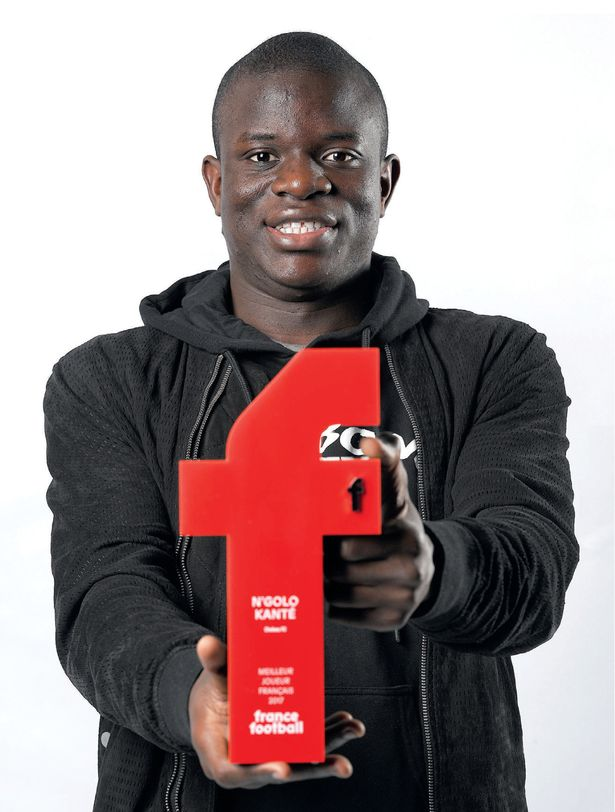How might this award impact the individual's future career and opportunities? Earning the 'Player of the Year' award can significantly impact the individual’s future career and opportunities. It increases his visibility and reputation within the sport, which might attract interest from top-tier clubs and sponsorship deals. Additionally, it can enhance his market value and bargaining power for contracts. The achievement also bolsters his legacy, potentially paving the way for roles beyond his playing career, such as coaching, mentoring, or sports commentary. 